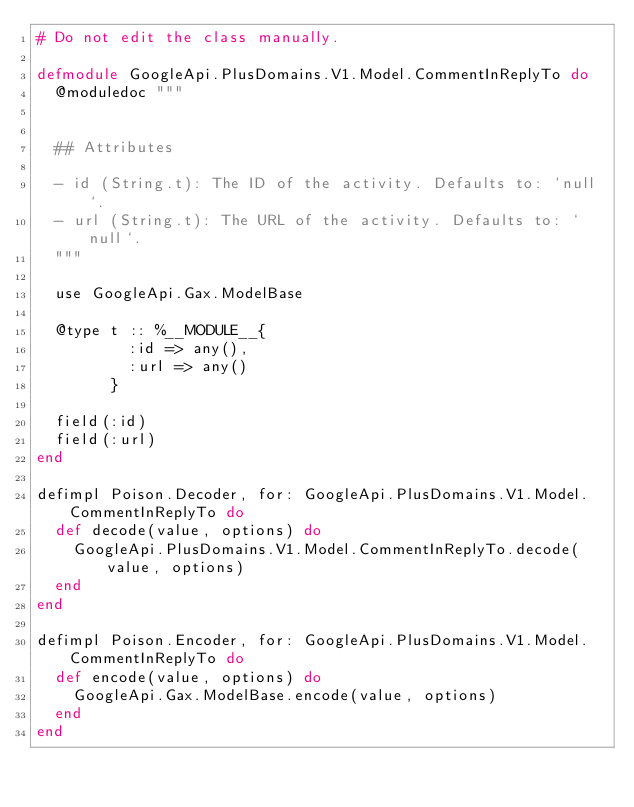<code> <loc_0><loc_0><loc_500><loc_500><_Elixir_># Do not edit the class manually.

defmodule GoogleApi.PlusDomains.V1.Model.CommentInReplyTo do
  @moduledoc """


  ## Attributes

  - id (String.t): The ID of the activity. Defaults to: `null`.
  - url (String.t): The URL of the activity. Defaults to: `null`.
  """

  use GoogleApi.Gax.ModelBase

  @type t :: %__MODULE__{
          :id => any(),
          :url => any()
        }

  field(:id)
  field(:url)
end

defimpl Poison.Decoder, for: GoogleApi.PlusDomains.V1.Model.CommentInReplyTo do
  def decode(value, options) do
    GoogleApi.PlusDomains.V1.Model.CommentInReplyTo.decode(value, options)
  end
end

defimpl Poison.Encoder, for: GoogleApi.PlusDomains.V1.Model.CommentInReplyTo do
  def encode(value, options) do
    GoogleApi.Gax.ModelBase.encode(value, options)
  end
end
</code> 